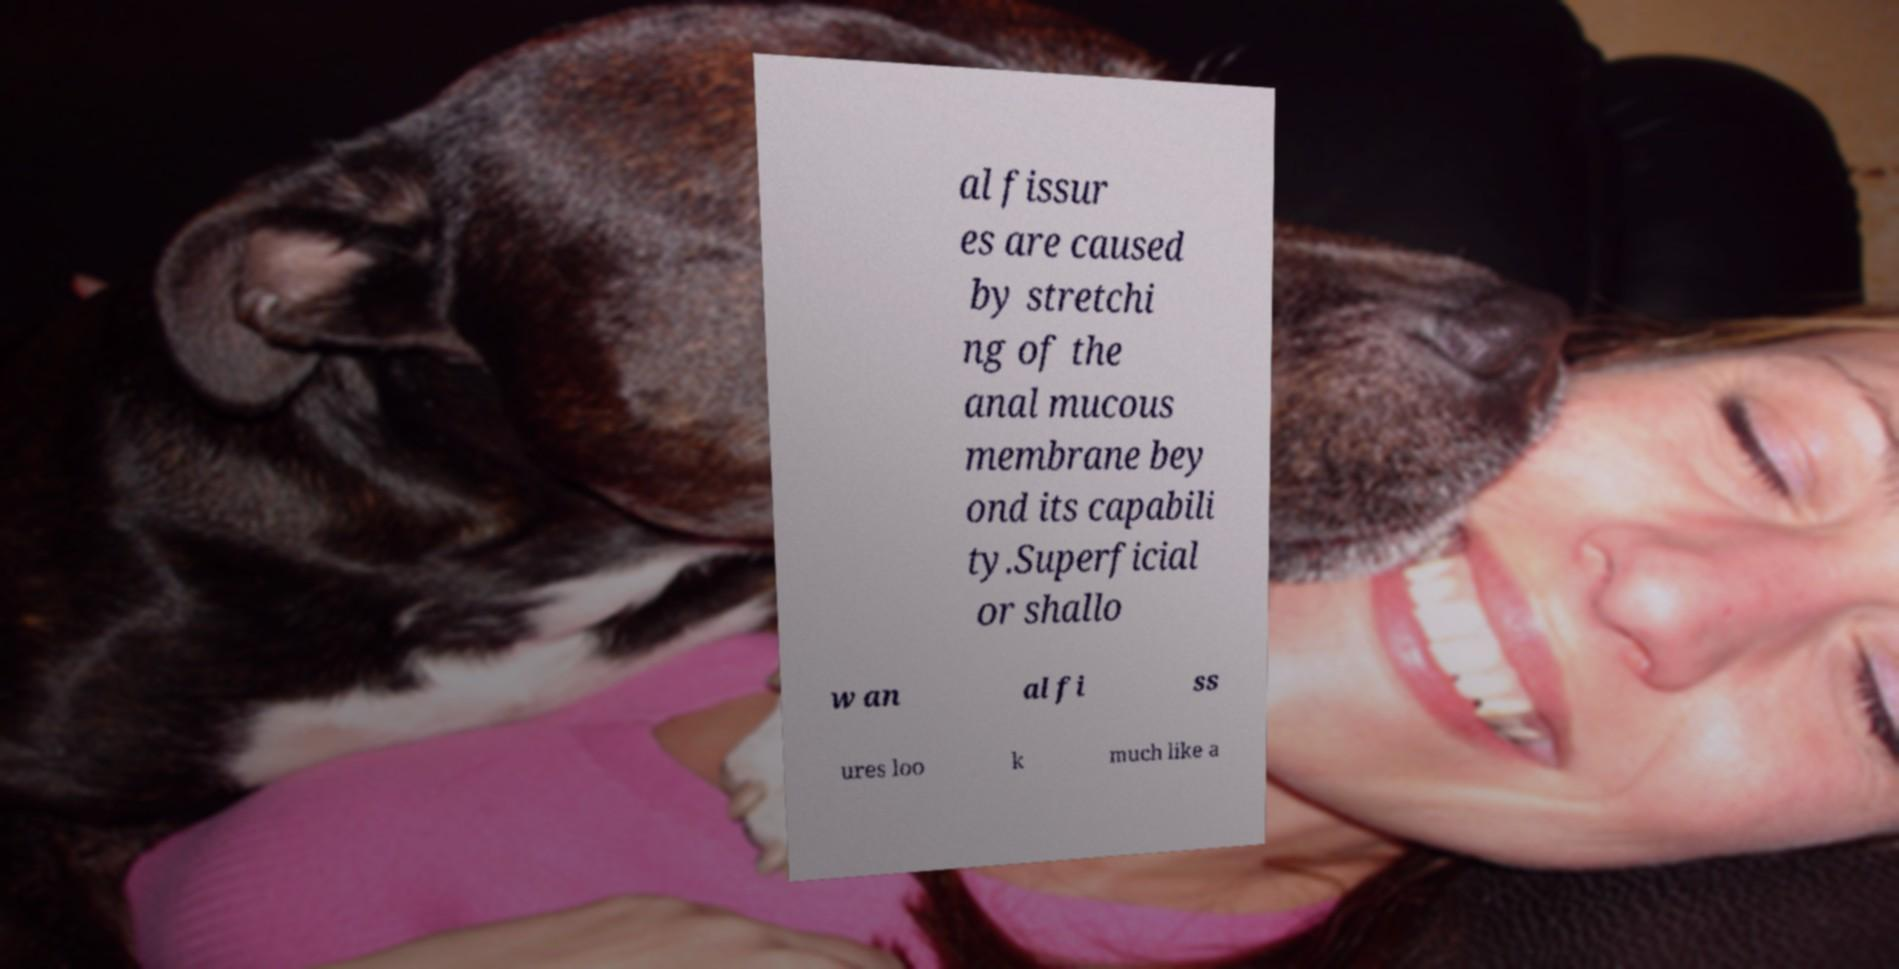Please identify and transcribe the text found in this image. al fissur es are caused by stretchi ng of the anal mucous membrane bey ond its capabili ty.Superficial or shallo w an al fi ss ures loo k much like a 